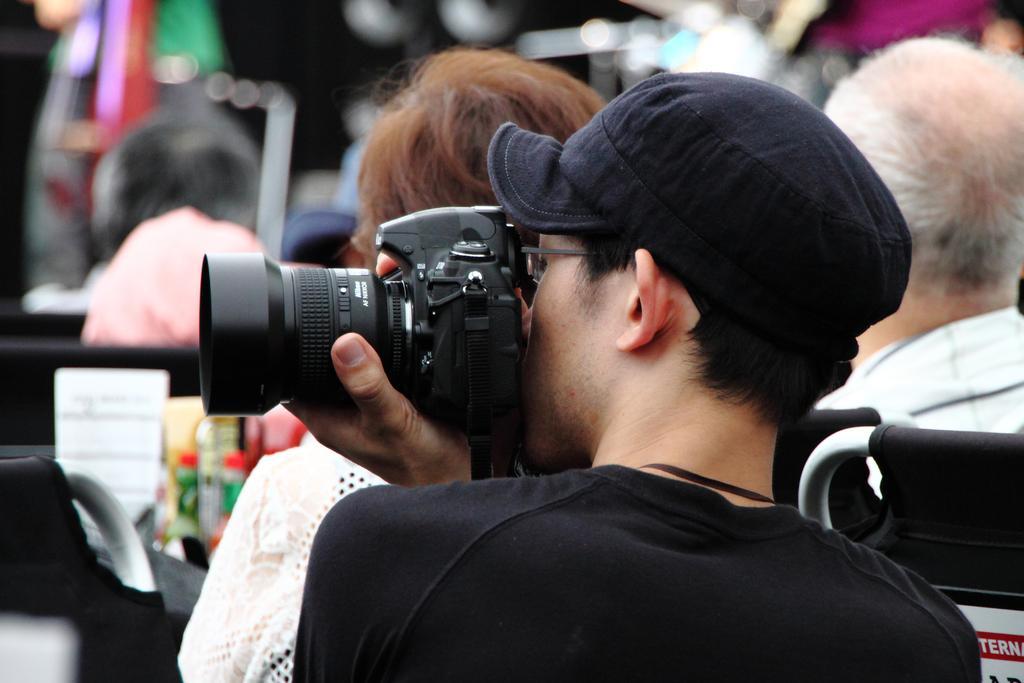Could you give a brief overview of what you see in this image? In this image there is a person wearing black color T-shirt and black color cap holding a camera in his left hand and at the background there are group of persons 